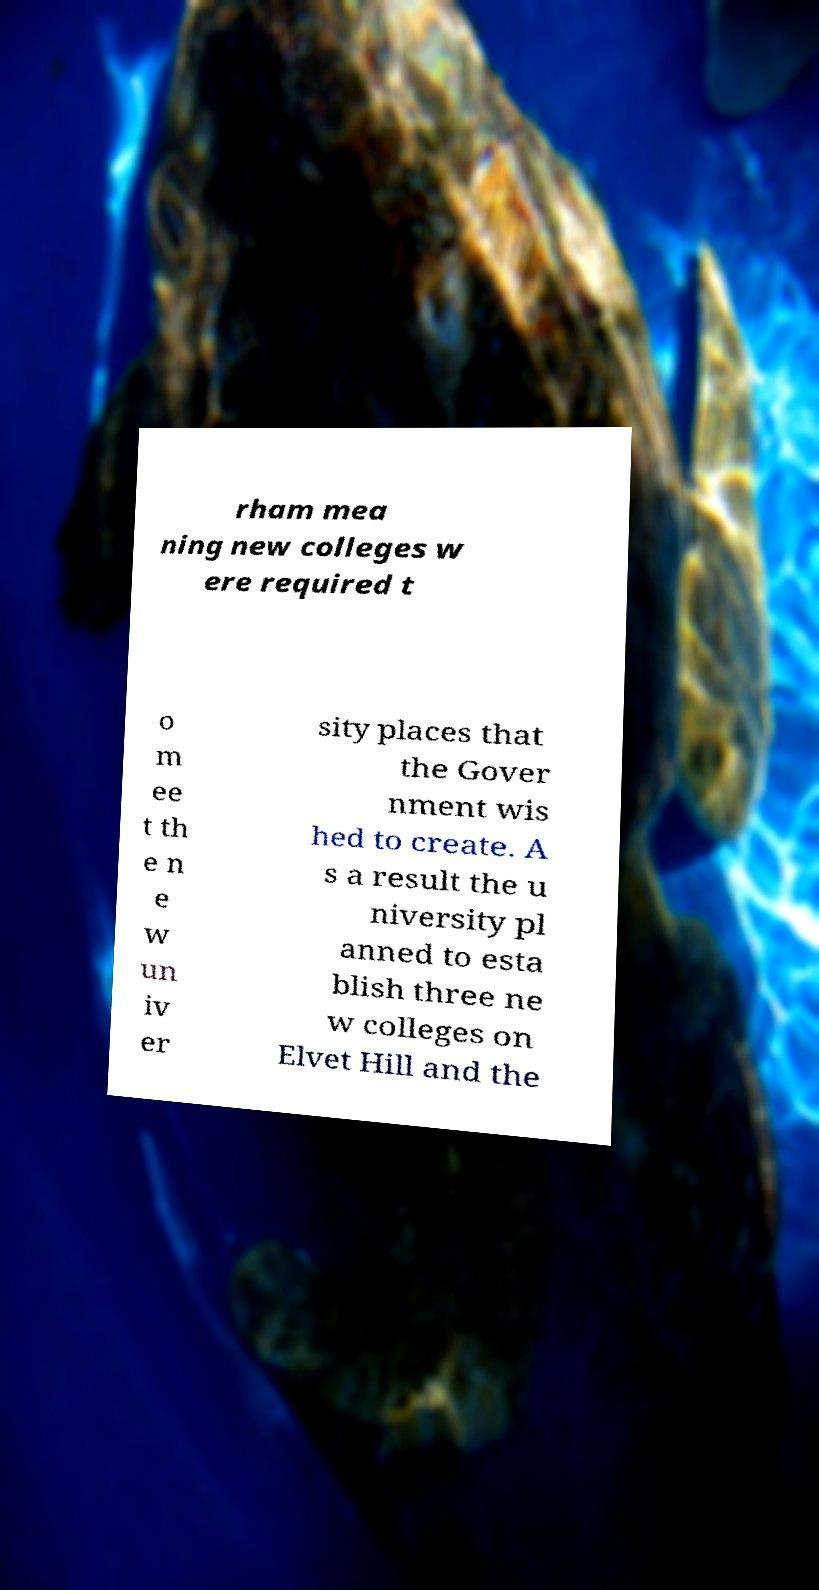Could you extract and type out the text from this image? rham mea ning new colleges w ere required t o m ee t th e n e w un iv er sity places that the Gover nment wis hed to create. A s a result the u niversity pl anned to esta blish three ne w colleges on Elvet Hill and the 